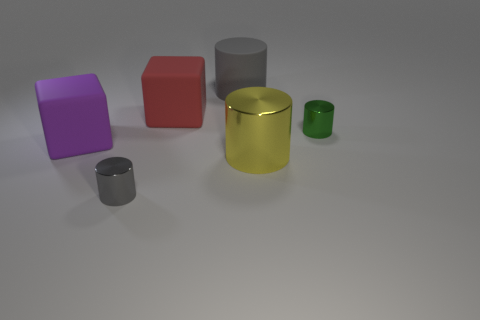Add 1 large things. How many objects exist? 7 Subtract all small gray cylinders. How many cylinders are left? 3 Subtract all green cylinders. How many cylinders are left? 3 Subtract 2 cylinders. How many cylinders are left? 2 Subtract all blocks. How many objects are left? 4 Subtract all blue cylinders. Subtract all red cubes. How many cylinders are left? 4 Subtract all brown spheres. How many brown blocks are left? 0 Subtract all tiny objects. Subtract all big purple blocks. How many objects are left? 3 Add 6 big red blocks. How many big red blocks are left? 7 Add 6 large purple rubber blocks. How many large purple rubber blocks exist? 7 